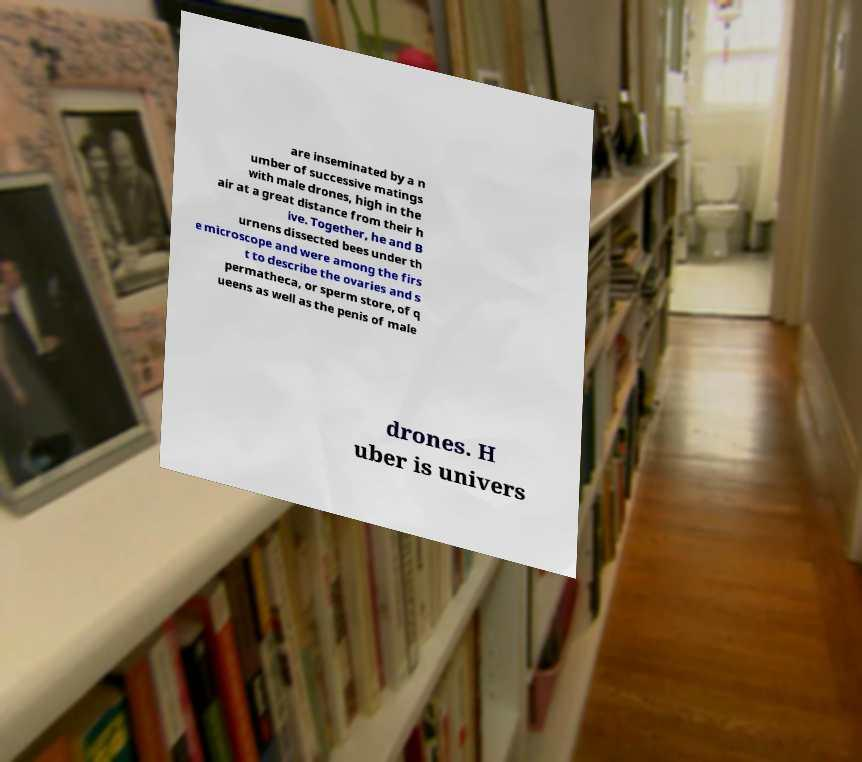There's text embedded in this image that I need extracted. Can you transcribe it verbatim? are inseminated by a n umber of successive matings with male drones, high in the air at a great distance from their h ive. Together, he and B urnens dissected bees under th e microscope and were among the firs t to describe the ovaries and s permatheca, or sperm store, of q ueens as well as the penis of male drones. H uber is univers 